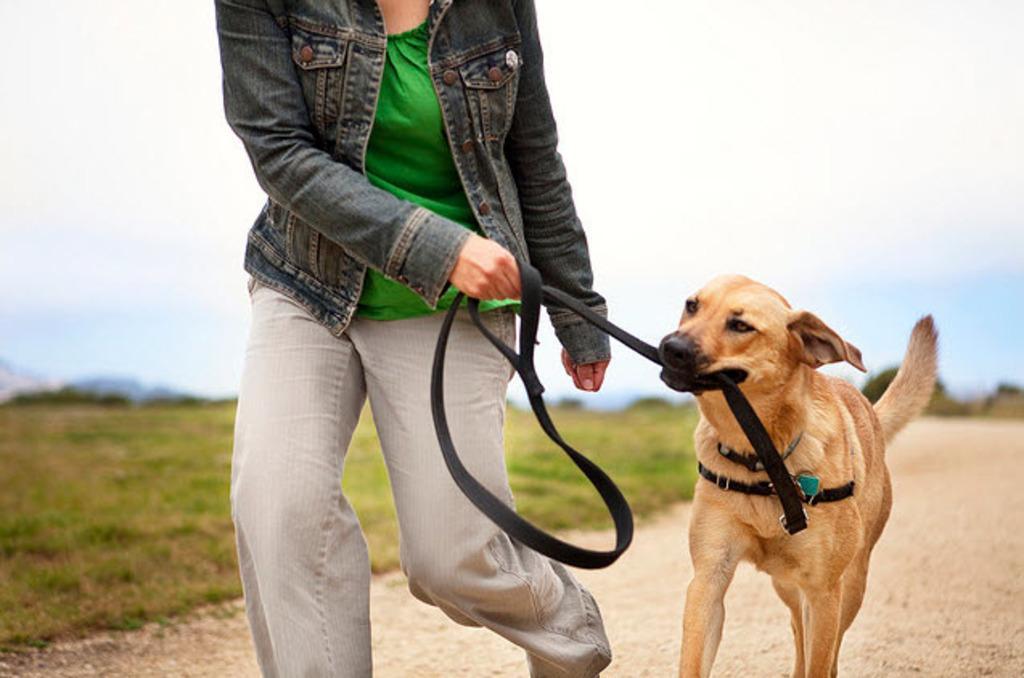Describe this image in one or two sentences. There is one person is walking on the road and holding a dog belt as we can see in the middle of this image. There is a dog on the right side of this image. There is a grassy land in the background, and there is a cloudy sky at the top of this image. 